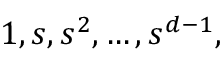<formula> <loc_0><loc_0><loc_500><loc_500>1 , s , s ^ { 2 } , \dots , s ^ { d - 1 } ,</formula> 